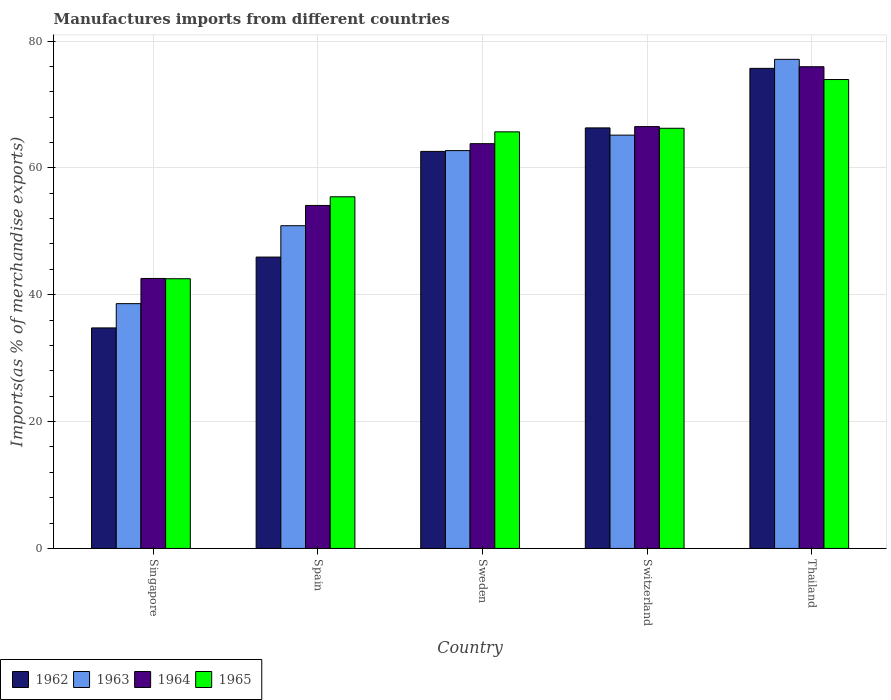How many bars are there on the 5th tick from the left?
Give a very brief answer. 4. How many bars are there on the 1st tick from the right?
Make the answer very short. 4. What is the label of the 5th group of bars from the left?
Your answer should be compact. Thailand. In how many cases, is the number of bars for a given country not equal to the number of legend labels?
Provide a short and direct response. 0. What is the percentage of imports to different countries in 1962 in Singapore?
Offer a terse response. 34.77. Across all countries, what is the maximum percentage of imports to different countries in 1964?
Provide a succinct answer. 75.95. Across all countries, what is the minimum percentage of imports to different countries in 1963?
Ensure brevity in your answer.  38.6. In which country was the percentage of imports to different countries in 1965 maximum?
Give a very brief answer. Thailand. In which country was the percentage of imports to different countries in 1964 minimum?
Give a very brief answer. Singapore. What is the total percentage of imports to different countries in 1964 in the graph?
Your answer should be very brief. 302.92. What is the difference between the percentage of imports to different countries in 1962 in Singapore and that in Thailand?
Offer a terse response. -40.92. What is the difference between the percentage of imports to different countries in 1962 in Sweden and the percentage of imports to different countries in 1963 in Spain?
Make the answer very short. 11.72. What is the average percentage of imports to different countries in 1965 per country?
Provide a short and direct response. 60.76. What is the difference between the percentage of imports to different countries of/in 1962 and percentage of imports to different countries of/in 1963 in Spain?
Your answer should be very brief. -4.94. What is the ratio of the percentage of imports to different countries in 1965 in Spain to that in Switzerland?
Ensure brevity in your answer.  0.84. What is the difference between the highest and the second highest percentage of imports to different countries in 1963?
Provide a short and direct response. -11.95. What is the difference between the highest and the lowest percentage of imports to different countries in 1962?
Offer a very short reply. 40.92. In how many countries, is the percentage of imports to different countries in 1962 greater than the average percentage of imports to different countries in 1962 taken over all countries?
Ensure brevity in your answer.  3. Is the sum of the percentage of imports to different countries in 1962 in Singapore and Sweden greater than the maximum percentage of imports to different countries in 1963 across all countries?
Offer a terse response. Yes. What does the 3rd bar from the left in Singapore represents?
Provide a short and direct response. 1964. Is it the case that in every country, the sum of the percentage of imports to different countries in 1965 and percentage of imports to different countries in 1962 is greater than the percentage of imports to different countries in 1964?
Provide a short and direct response. Yes. What is the difference between two consecutive major ticks on the Y-axis?
Make the answer very short. 20. Does the graph contain grids?
Offer a terse response. Yes. How many legend labels are there?
Make the answer very short. 4. What is the title of the graph?
Offer a very short reply. Manufactures imports from different countries. Does "1975" appear as one of the legend labels in the graph?
Your answer should be compact. No. What is the label or title of the X-axis?
Your response must be concise. Country. What is the label or title of the Y-axis?
Provide a succinct answer. Imports(as % of merchandise exports). What is the Imports(as % of merchandise exports) in 1962 in Singapore?
Offer a terse response. 34.77. What is the Imports(as % of merchandise exports) of 1963 in Singapore?
Offer a terse response. 38.6. What is the Imports(as % of merchandise exports) in 1964 in Singapore?
Your answer should be compact. 42.56. What is the Imports(as % of merchandise exports) in 1965 in Singapore?
Your answer should be very brief. 42.52. What is the Imports(as % of merchandise exports) of 1962 in Spain?
Give a very brief answer. 45.94. What is the Imports(as % of merchandise exports) in 1963 in Spain?
Offer a very short reply. 50.88. What is the Imports(as % of merchandise exports) in 1964 in Spain?
Provide a short and direct response. 54.08. What is the Imports(as % of merchandise exports) in 1965 in Spain?
Ensure brevity in your answer.  55.44. What is the Imports(as % of merchandise exports) in 1962 in Sweden?
Make the answer very short. 62.6. What is the Imports(as % of merchandise exports) in 1963 in Sweden?
Your response must be concise. 62.72. What is the Imports(as % of merchandise exports) of 1964 in Sweden?
Your answer should be compact. 63.82. What is the Imports(as % of merchandise exports) in 1965 in Sweden?
Your answer should be compact. 65.68. What is the Imports(as % of merchandise exports) of 1962 in Switzerland?
Provide a succinct answer. 66.31. What is the Imports(as % of merchandise exports) of 1963 in Switzerland?
Your answer should be very brief. 65.16. What is the Imports(as % of merchandise exports) of 1964 in Switzerland?
Provide a short and direct response. 66.51. What is the Imports(as % of merchandise exports) of 1965 in Switzerland?
Ensure brevity in your answer.  66.24. What is the Imports(as % of merchandise exports) of 1962 in Thailand?
Offer a terse response. 75.69. What is the Imports(as % of merchandise exports) in 1963 in Thailand?
Provide a succinct answer. 77.12. What is the Imports(as % of merchandise exports) in 1964 in Thailand?
Your answer should be compact. 75.95. What is the Imports(as % of merchandise exports) of 1965 in Thailand?
Offer a terse response. 73.93. Across all countries, what is the maximum Imports(as % of merchandise exports) of 1962?
Offer a very short reply. 75.69. Across all countries, what is the maximum Imports(as % of merchandise exports) in 1963?
Offer a terse response. 77.12. Across all countries, what is the maximum Imports(as % of merchandise exports) of 1964?
Make the answer very short. 75.95. Across all countries, what is the maximum Imports(as % of merchandise exports) in 1965?
Give a very brief answer. 73.93. Across all countries, what is the minimum Imports(as % of merchandise exports) in 1962?
Your answer should be compact. 34.77. Across all countries, what is the minimum Imports(as % of merchandise exports) of 1963?
Make the answer very short. 38.6. Across all countries, what is the minimum Imports(as % of merchandise exports) in 1964?
Provide a succinct answer. 42.56. Across all countries, what is the minimum Imports(as % of merchandise exports) in 1965?
Ensure brevity in your answer.  42.52. What is the total Imports(as % of merchandise exports) in 1962 in the graph?
Keep it short and to the point. 285.31. What is the total Imports(as % of merchandise exports) in 1963 in the graph?
Offer a terse response. 294.48. What is the total Imports(as % of merchandise exports) in 1964 in the graph?
Offer a very short reply. 302.92. What is the total Imports(as % of merchandise exports) of 1965 in the graph?
Keep it short and to the point. 303.82. What is the difference between the Imports(as % of merchandise exports) of 1962 in Singapore and that in Spain?
Your response must be concise. -11.17. What is the difference between the Imports(as % of merchandise exports) in 1963 in Singapore and that in Spain?
Your answer should be very brief. -12.29. What is the difference between the Imports(as % of merchandise exports) of 1964 in Singapore and that in Spain?
Make the answer very short. -11.51. What is the difference between the Imports(as % of merchandise exports) of 1965 in Singapore and that in Spain?
Your answer should be very brief. -12.92. What is the difference between the Imports(as % of merchandise exports) in 1962 in Singapore and that in Sweden?
Your response must be concise. -27.83. What is the difference between the Imports(as % of merchandise exports) of 1963 in Singapore and that in Sweden?
Ensure brevity in your answer.  -24.13. What is the difference between the Imports(as % of merchandise exports) in 1964 in Singapore and that in Sweden?
Make the answer very short. -21.25. What is the difference between the Imports(as % of merchandise exports) of 1965 in Singapore and that in Sweden?
Your answer should be very brief. -23.16. What is the difference between the Imports(as % of merchandise exports) of 1962 in Singapore and that in Switzerland?
Offer a very short reply. -31.54. What is the difference between the Imports(as % of merchandise exports) of 1963 in Singapore and that in Switzerland?
Ensure brevity in your answer.  -26.57. What is the difference between the Imports(as % of merchandise exports) in 1964 in Singapore and that in Switzerland?
Keep it short and to the point. -23.94. What is the difference between the Imports(as % of merchandise exports) of 1965 in Singapore and that in Switzerland?
Provide a succinct answer. -23.72. What is the difference between the Imports(as % of merchandise exports) of 1962 in Singapore and that in Thailand?
Offer a terse response. -40.92. What is the difference between the Imports(as % of merchandise exports) of 1963 in Singapore and that in Thailand?
Provide a succinct answer. -38.52. What is the difference between the Imports(as % of merchandise exports) in 1964 in Singapore and that in Thailand?
Your answer should be very brief. -33.38. What is the difference between the Imports(as % of merchandise exports) of 1965 in Singapore and that in Thailand?
Your response must be concise. -31.41. What is the difference between the Imports(as % of merchandise exports) in 1962 in Spain and that in Sweden?
Give a very brief answer. -16.66. What is the difference between the Imports(as % of merchandise exports) of 1963 in Spain and that in Sweden?
Your answer should be very brief. -11.84. What is the difference between the Imports(as % of merchandise exports) in 1964 in Spain and that in Sweden?
Your response must be concise. -9.74. What is the difference between the Imports(as % of merchandise exports) in 1965 in Spain and that in Sweden?
Offer a very short reply. -10.24. What is the difference between the Imports(as % of merchandise exports) in 1962 in Spain and that in Switzerland?
Your answer should be compact. -20.37. What is the difference between the Imports(as % of merchandise exports) of 1963 in Spain and that in Switzerland?
Your answer should be very brief. -14.28. What is the difference between the Imports(as % of merchandise exports) of 1964 in Spain and that in Switzerland?
Ensure brevity in your answer.  -12.43. What is the difference between the Imports(as % of merchandise exports) in 1965 in Spain and that in Switzerland?
Provide a succinct answer. -10.8. What is the difference between the Imports(as % of merchandise exports) of 1962 in Spain and that in Thailand?
Your answer should be very brief. -29.75. What is the difference between the Imports(as % of merchandise exports) in 1963 in Spain and that in Thailand?
Give a very brief answer. -26.23. What is the difference between the Imports(as % of merchandise exports) of 1964 in Spain and that in Thailand?
Offer a terse response. -21.87. What is the difference between the Imports(as % of merchandise exports) in 1965 in Spain and that in Thailand?
Offer a terse response. -18.49. What is the difference between the Imports(as % of merchandise exports) of 1962 in Sweden and that in Switzerland?
Your answer should be very brief. -3.71. What is the difference between the Imports(as % of merchandise exports) in 1963 in Sweden and that in Switzerland?
Provide a succinct answer. -2.44. What is the difference between the Imports(as % of merchandise exports) in 1964 in Sweden and that in Switzerland?
Your response must be concise. -2.69. What is the difference between the Imports(as % of merchandise exports) in 1965 in Sweden and that in Switzerland?
Provide a succinct answer. -0.56. What is the difference between the Imports(as % of merchandise exports) in 1962 in Sweden and that in Thailand?
Offer a terse response. -13.09. What is the difference between the Imports(as % of merchandise exports) of 1963 in Sweden and that in Thailand?
Give a very brief answer. -14.39. What is the difference between the Imports(as % of merchandise exports) in 1964 in Sweden and that in Thailand?
Your response must be concise. -12.13. What is the difference between the Imports(as % of merchandise exports) of 1965 in Sweden and that in Thailand?
Ensure brevity in your answer.  -8.25. What is the difference between the Imports(as % of merchandise exports) of 1962 in Switzerland and that in Thailand?
Give a very brief answer. -9.39. What is the difference between the Imports(as % of merchandise exports) in 1963 in Switzerland and that in Thailand?
Ensure brevity in your answer.  -11.95. What is the difference between the Imports(as % of merchandise exports) of 1964 in Switzerland and that in Thailand?
Your response must be concise. -9.44. What is the difference between the Imports(as % of merchandise exports) in 1965 in Switzerland and that in Thailand?
Offer a very short reply. -7.69. What is the difference between the Imports(as % of merchandise exports) in 1962 in Singapore and the Imports(as % of merchandise exports) in 1963 in Spain?
Offer a terse response. -16.11. What is the difference between the Imports(as % of merchandise exports) in 1962 in Singapore and the Imports(as % of merchandise exports) in 1964 in Spain?
Provide a succinct answer. -19.31. What is the difference between the Imports(as % of merchandise exports) of 1962 in Singapore and the Imports(as % of merchandise exports) of 1965 in Spain?
Give a very brief answer. -20.68. What is the difference between the Imports(as % of merchandise exports) of 1963 in Singapore and the Imports(as % of merchandise exports) of 1964 in Spain?
Offer a very short reply. -15.48. What is the difference between the Imports(as % of merchandise exports) of 1963 in Singapore and the Imports(as % of merchandise exports) of 1965 in Spain?
Make the answer very short. -16.85. What is the difference between the Imports(as % of merchandise exports) of 1964 in Singapore and the Imports(as % of merchandise exports) of 1965 in Spain?
Offer a very short reply. -12.88. What is the difference between the Imports(as % of merchandise exports) in 1962 in Singapore and the Imports(as % of merchandise exports) in 1963 in Sweden?
Give a very brief answer. -27.95. What is the difference between the Imports(as % of merchandise exports) of 1962 in Singapore and the Imports(as % of merchandise exports) of 1964 in Sweden?
Give a very brief answer. -29.05. What is the difference between the Imports(as % of merchandise exports) in 1962 in Singapore and the Imports(as % of merchandise exports) in 1965 in Sweden?
Give a very brief answer. -30.91. What is the difference between the Imports(as % of merchandise exports) of 1963 in Singapore and the Imports(as % of merchandise exports) of 1964 in Sweden?
Make the answer very short. -25.22. What is the difference between the Imports(as % of merchandise exports) in 1963 in Singapore and the Imports(as % of merchandise exports) in 1965 in Sweden?
Provide a short and direct response. -27.09. What is the difference between the Imports(as % of merchandise exports) in 1964 in Singapore and the Imports(as % of merchandise exports) in 1965 in Sweden?
Ensure brevity in your answer.  -23.12. What is the difference between the Imports(as % of merchandise exports) in 1962 in Singapore and the Imports(as % of merchandise exports) in 1963 in Switzerland?
Give a very brief answer. -30.4. What is the difference between the Imports(as % of merchandise exports) in 1962 in Singapore and the Imports(as % of merchandise exports) in 1964 in Switzerland?
Offer a very short reply. -31.74. What is the difference between the Imports(as % of merchandise exports) of 1962 in Singapore and the Imports(as % of merchandise exports) of 1965 in Switzerland?
Ensure brevity in your answer.  -31.48. What is the difference between the Imports(as % of merchandise exports) in 1963 in Singapore and the Imports(as % of merchandise exports) in 1964 in Switzerland?
Give a very brief answer. -27.91. What is the difference between the Imports(as % of merchandise exports) in 1963 in Singapore and the Imports(as % of merchandise exports) in 1965 in Switzerland?
Ensure brevity in your answer.  -27.65. What is the difference between the Imports(as % of merchandise exports) of 1964 in Singapore and the Imports(as % of merchandise exports) of 1965 in Switzerland?
Your response must be concise. -23.68. What is the difference between the Imports(as % of merchandise exports) of 1962 in Singapore and the Imports(as % of merchandise exports) of 1963 in Thailand?
Ensure brevity in your answer.  -42.35. What is the difference between the Imports(as % of merchandise exports) of 1962 in Singapore and the Imports(as % of merchandise exports) of 1964 in Thailand?
Keep it short and to the point. -41.18. What is the difference between the Imports(as % of merchandise exports) in 1962 in Singapore and the Imports(as % of merchandise exports) in 1965 in Thailand?
Give a very brief answer. -39.16. What is the difference between the Imports(as % of merchandise exports) in 1963 in Singapore and the Imports(as % of merchandise exports) in 1964 in Thailand?
Provide a short and direct response. -37.35. What is the difference between the Imports(as % of merchandise exports) in 1963 in Singapore and the Imports(as % of merchandise exports) in 1965 in Thailand?
Your response must be concise. -35.34. What is the difference between the Imports(as % of merchandise exports) of 1964 in Singapore and the Imports(as % of merchandise exports) of 1965 in Thailand?
Offer a very short reply. -31.37. What is the difference between the Imports(as % of merchandise exports) of 1962 in Spain and the Imports(as % of merchandise exports) of 1963 in Sweden?
Provide a short and direct response. -16.78. What is the difference between the Imports(as % of merchandise exports) in 1962 in Spain and the Imports(as % of merchandise exports) in 1964 in Sweden?
Make the answer very short. -17.88. What is the difference between the Imports(as % of merchandise exports) of 1962 in Spain and the Imports(as % of merchandise exports) of 1965 in Sweden?
Your answer should be very brief. -19.74. What is the difference between the Imports(as % of merchandise exports) of 1963 in Spain and the Imports(as % of merchandise exports) of 1964 in Sweden?
Keep it short and to the point. -12.94. What is the difference between the Imports(as % of merchandise exports) in 1963 in Spain and the Imports(as % of merchandise exports) in 1965 in Sweden?
Give a very brief answer. -14.8. What is the difference between the Imports(as % of merchandise exports) of 1964 in Spain and the Imports(as % of merchandise exports) of 1965 in Sweden?
Give a very brief answer. -11.6. What is the difference between the Imports(as % of merchandise exports) of 1962 in Spain and the Imports(as % of merchandise exports) of 1963 in Switzerland?
Your response must be concise. -19.23. What is the difference between the Imports(as % of merchandise exports) in 1962 in Spain and the Imports(as % of merchandise exports) in 1964 in Switzerland?
Ensure brevity in your answer.  -20.57. What is the difference between the Imports(as % of merchandise exports) of 1962 in Spain and the Imports(as % of merchandise exports) of 1965 in Switzerland?
Make the answer very short. -20.31. What is the difference between the Imports(as % of merchandise exports) in 1963 in Spain and the Imports(as % of merchandise exports) in 1964 in Switzerland?
Ensure brevity in your answer.  -15.63. What is the difference between the Imports(as % of merchandise exports) of 1963 in Spain and the Imports(as % of merchandise exports) of 1965 in Switzerland?
Your response must be concise. -15.36. What is the difference between the Imports(as % of merchandise exports) in 1964 in Spain and the Imports(as % of merchandise exports) in 1965 in Switzerland?
Offer a very short reply. -12.17. What is the difference between the Imports(as % of merchandise exports) in 1962 in Spain and the Imports(as % of merchandise exports) in 1963 in Thailand?
Offer a very short reply. -31.18. What is the difference between the Imports(as % of merchandise exports) of 1962 in Spain and the Imports(as % of merchandise exports) of 1964 in Thailand?
Offer a very short reply. -30.01. What is the difference between the Imports(as % of merchandise exports) of 1962 in Spain and the Imports(as % of merchandise exports) of 1965 in Thailand?
Your answer should be very brief. -27.99. What is the difference between the Imports(as % of merchandise exports) in 1963 in Spain and the Imports(as % of merchandise exports) in 1964 in Thailand?
Provide a short and direct response. -25.07. What is the difference between the Imports(as % of merchandise exports) of 1963 in Spain and the Imports(as % of merchandise exports) of 1965 in Thailand?
Make the answer very short. -23.05. What is the difference between the Imports(as % of merchandise exports) of 1964 in Spain and the Imports(as % of merchandise exports) of 1965 in Thailand?
Give a very brief answer. -19.85. What is the difference between the Imports(as % of merchandise exports) of 1962 in Sweden and the Imports(as % of merchandise exports) of 1963 in Switzerland?
Offer a terse response. -2.57. What is the difference between the Imports(as % of merchandise exports) in 1962 in Sweden and the Imports(as % of merchandise exports) in 1964 in Switzerland?
Provide a short and direct response. -3.91. What is the difference between the Imports(as % of merchandise exports) of 1962 in Sweden and the Imports(as % of merchandise exports) of 1965 in Switzerland?
Provide a succinct answer. -3.65. What is the difference between the Imports(as % of merchandise exports) of 1963 in Sweden and the Imports(as % of merchandise exports) of 1964 in Switzerland?
Your answer should be very brief. -3.78. What is the difference between the Imports(as % of merchandise exports) of 1963 in Sweden and the Imports(as % of merchandise exports) of 1965 in Switzerland?
Ensure brevity in your answer.  -3.52. What is the difference between the Imports(as % of merchandise exports) of 1964 in Sweden and the Imports(as % of merchandise exports) of 1965 in Switzerland?
Offer a very short reply. -2.43. What is the difference between the Imports(as % of merchandise exports) in 1962 in Sweden and the Imports(as % of merchandise exports) in 1963 in Thailand?
Offer a terse response. -14.52. What is the difference between the Imports(as % of merchandise exports) of 1962 in Sweden and the Imports(as % of merchandise exports) of 1964 in Thailand?
Provide a short and direct response. -13.35. What is the difference between the Imports(as % of merchandise exports) in 1962 in Sweden and the Imports(as % of merchandise exports) in 1965 in Thailand?
Make the answer very short. -11.33. What is the difference between the Imports(as % of merchandise exports) in 1963 in Sweden and the Imports(as % of merchandise exports) in 1964 in Thailand?
Provide a short and direct response. -13.23. What is the difference between the Imports(as % of merchandise exports) in 1963 in Sweden and the Imports(as % of merchandise exports) in 1965 in Thailand?
Your answer should be compact. -11.21. What is the difference between the Imports(as % of merchandise exports) in 1964 in Sweden and the Imports(as % of merchandise exports) in 1965 in Thailand?
Give a very brief answer. -10.11. What is the difference between the Imports(as % of merchandise exports) in 1962 in Switzerland and the Imports(as % of merchandise exports) in 1963 in Thailand?
Ensure brevity in your answer.  -10.81. What is the difference between the Imports(as % of merchandise exports) in 1962 in Switzerland and the Imports(as % of merchandise exports) in 1964 in Thailand?
Provide a short and direct response. -9.64. What is the difference between the Imports(as % of merchandise exports) in 1962 in Switzerland and the Imports(as % of merchandise exports) in 1965 in Thailand?
Your answer should be very brief. -7.63. What is the difference between the Imports(as % of merchandise exports) of 1963 in Switzerland and the Imports(as % of merchandise exports) of 1964 in Thailand?
Provide a succinct answer. -10.78. What is the difference between the Imports(as % of merchandise exports) in 1963 in Switzerland and the Imports(as % of merchandise exports) in 1965 in Thailand?
Your answer should be compact. -8.77. What is the difference between the Imports(as % of merchandise exports) in 1964 in Switzerland and the Imports(as % of merchandise exports) in 1965 in Thailand?
Keep it short and to the point. -7.42. What is the average Imports(as % of merchandise exports) of 1962 per country?
Offer a terse response. 57.06. What is the average Imports(as % of merchandise exports) in 1963 per country?
Your answer should be compact. 58.9. What is the average Imports(as % of merchandise exports) in 1964 per country?
Your response must be concise. 60.58. What is the average Imports(as % of merchandise exports) of 1965 per country?
Give a very brief answer. 60.76. What is the difference between the Imports(as % of merchandise exports) of 1962 and Imports(as % of merchandise exports) of 1963 in Singapore?
Provide a short and direct response. -3.83. What is the difference between the Imports(as % of merchandise exports) of 1962 and Imports(as % of merchandise exports) of 1964 in Singapore?
Your answer should be very brief. -7.8. What is the difference between the Imports(as % of merchandise exports) of 1962 and Imports(as % of merchandise exports) of 1965 in Singapore?
Give a very brief answer. -7.75. What is the difference between the Imports(as % of merchandise exports) of 1963 and Imports(as % of merchandise exports) of 1964 in Singapore?
Provide a short and direct response. -3.97. What is the difference between the Imports(as % of merchandise exports) of 1963 and Imports(as % of merchandise exports) of 1965 in Singapore?
Keep it short and to the point. -3.93. What is the difference between the Imports(as % of merchandise exports) of 1964 and Imports(as % of merchandise exports) of 1965 in Singapore?
Give a very brief answer. 0.04. What is the difference between the Imports(as % of merchandise exports) in 1962 and Imports(as % of merchandise exports) in 1963 in Spain?
Offer a very short reply. -4.94. What is the difference between the Imports(as % of merchandise exports) of 1962 and Imports(as % of merchandise exports) of 1964 in Spain?
Keep it short and to the point. -8.14. What is the difference between the Imports(as % of merchandise exports) of 1962 and Imports(as % of merchandise exports) of 1965 in Spain?
Make the answer very short. -9.51. What is the difference between the Imports(as % of merchandise exports) in 1963 and Imports(as % of merchandise exports) in 1964 in Spain?
Offer a very short reply. -3.2. What is the difference between the Imports(as % of merchandise exports) in 1963 and Imports(as % of merchandise exports) in 1965 in Spain?
Ensure brevity in your answer.  -4.56. What is the difference between the Imports(as % of merchandise exports) in 1964 and Imports(as % of merchandise exports) in 1965 in Spain?
Keep it short and to the point. -1.37. What is the difference between the Imports(as % of merchandise exports) in 1962 and Imports(as % of merchandise exports) in 1963 in Sweden?
Your response must be concise. -0.12. What is the difference between the Imports(as % of merchandise exports) in 1962 and Imports(as % of merchandise exports) in 1964 in Sweden?
Keep it short and to the point. -1.22. What is the difference between the Imports(as % of merchandise exports) in 1962 and Imports(as % of merchandise exports) in 1965 in Sweden?
Provide a short and direct response. -3.08. What is the difference between the Imports(as % of merchandise exports) in 1963 and Imports(as % of merchandise exports) in 1964 in Sweden?
Your answer should be very brief. -1.09. What is the difference between the Imports(as % of merchandise exports) in 1963 and Imports(as % of merchandise exports) in 1965 in Sweden?
Keep it short and to the point. -2.96. What is the difference between the Imports(as % of merchandise exports) of 1964 and Imports(as % of merchandise exports) of 1965 in Sweden?
Give a very brief answer. -1.87. What is the difference between the Imports(as % of merchandise exports) in 1962 and Imports(as % of merchandise exports) in 1963 in Switzerland?
Your response must be concise. 1.14. What is the difference between the Imports(as % of merchandise exports) in 1962 and Imports(as % of merchandise exports) in 1964 in Switzerland?
Provide a short and direct response. -0.2. What is the difference between the Imports(as % of merchandise exports) in 1962 and Imports(as % of merchandise exports) in 1965 in Switzerland?
Offer a terse response. 0.06. What is the difference between the Imports(as % of merchandise exports) in 1963 and Imports(as % of merchandise exports) in 1964 in Switzerland?
Offer a terse response. -1.34. What is the difference between the Imports(as % of merchandise exports) in 1963 and Imports(as % of merchandise exports) in 1965 in Switzerland?
Offer a very short reply. -1.08. What is the difference between the Imports(as % of merchandise exports) of 1964 and Imports(as % of merchandise exports) of 1965 in Switzerland?
Give a very brief answer. 0.26. What is the difference between the Imports(as % of merchandise exports) of 1962 and Imports(as % of merchandise exports) of 1963 in Thailand?
Your response must be concise. -1.42. What is the difference between the Imports(as % of merchandise exports) in 1962 and Imports(as % of merchandise exports) in 1964 in Thailand?
Keep it short and to the point. -0.26. What is the difference between the Imports(as % of merchandise exports) of 1962 and Imports(as % of merchandise exports) of 1965 in Thailand?
Keep it short and to the point. 1.76. What is the difference between the Imports(as % of merchandise exports) in 1963 and Imports(as % of merchandise exports) in 1964 in Thailand?
Your answer should be compact. 1.17. What is the difference between the Imports(as % of merchandise exports) in 1963 and Imports(as % of merchandise exports) in 1965 in Thailand?
Your answer should be compact. 3.18. What is the difference between the Imports(as % of merchandise exports) in 1964 and Imports(as % of merchandise exports) in 1965 in Thailand?
Offer a terse response. 2.02. What is the ratio of the Imports(as % of merchandise exports) in 1962 in Singapore to that in Spain?
Your response must be concise. 0.76. What is the ratio of the Imports(as % of merchandise exports) in 1963 in Singapore to that in Spain?
Your answer should be compact. 0.76. What is the ratio of the Imports(as % of merchandise exports) in 1964 in Singapore to that in Spain?
Your answer should be very brief. 0.79. What is the ratio of the Imports(as % of merchandise exports) in 1965 in Singapore to that in Spain?
Provide a succinct answer. 0.77. What is the ratio of the Imports(as % of merchandise exports) of 1962 in Singapore to that in Sweden?
Offer a terse response. 0.56. What is the ratio of the Imports(as % of merchandise exports) in 1963 in Singapore to that in Sweden?
Your answer should be very brief. 0.62. What is the ratio of the Imports(as % of merchandise exports) of 1964 in Singapore to that in Sweden?
Your answer should be compact. 0.67. What is the ratio of the Imports(as % of merchandise exports) of 1965 in Singapore to that in Sweden?
Keep it short and to the point. 0.65. What is the ratio of the Imports(as % of merchandise exports) of 1962 in Singapore to that in Switzerland?
Offer a terse response. 0.52. What is the ratio of the Imports(as % of merchandise exports) in 1963 in Singapore to that in Switzerland?
Provide a succinct answer. 0.59. What is the ratio of the Imports(as % of merchandise exports) in 1964 in Singapore to that in Switzerland?
Your answer should be compact. 0.64. What is the ratio of the Imports(as % of merchandise exports) of 1965 in Singapore to that in Switzerland?
Your response must be concise. 0.64. What is the ratio of the Imports(as % of merchandise exports) of 1962 in Singapore to that in Thailand?
Offer a very short reply. 0.46. What is the ratio of the Imports(as % of merchandise exports) of 1963 in Singapore to that in Thailand?
Keep it short and to the point. 0.5. What is the ratio of the Imports(as % of merchandise exports) of 1964 in Singapore to that in Thailand?
Give a very brief answer. 0.56. What is the ratio of the Imports(as % of merchandise exports) of 1965 in Singapore to that in Thailand?
Give a very brief answer. 0.58. What is the ratio of the Imports(as % of merchandise exports) in 1962 in Spain to that in Sweden?
Offer a terse response. 0.73. What is the ratio of the Imports(as % of merchandise exports) of 1963 in Spain to that in Sweden?
Provide a short and direct response. 0.81. What is the ratio of the Imports(as % of merchandise exports) in 1964 in Spain to that in Sweden?
Ensure brevity in your answer.  0.85. What is the ratio of the Imports(as % of merchandise exports) in 1965 in Spain to that in Sweden?
Your answer should be very brief. 0.84. What is the ratio of the Imports(as % of merchandise exports) in 1962 in Spain to that in Switzerland?
Your response must be concise. 0.69. What is the ratio of the Imports(as % of merchandise exports) of 1963 in Spain to that in Switzerland?
Provide a succinct answer. 0.78. What is the ratio of the Imports(as % of merchandise exports) in 1964 in Spain to that in Switzerland?
Your answer should be very brief. 0.81. What is the ratio of the Imports(as % of merchandise exports) in 1965 in Spain to that in Switzerland?
Your answer should be compact. 0.84. What is the ratio of the Imports(as % of merchandise exports) of 1962 in Spain to that in Thailand?
Provide a short and direct response. 0.61. What is the ratio of the Imports(as % of merchandise exports) of 1963 in Spain to that in Thailand?
Offer a terse response. 0.66. What is the ratio of the Imports(as % of merchandise exports) of 1964 in Spain to that in Thailand?
Your answer should be compact. 0.71. What is the ratio of the Imports(as % of merchandise exports) in 1965 in Spain to that in Thailand?
Your answer should be compact. 0.75. What is the ratio of the Imports(as % of merchandise exports) in 1962 in Sweden to that in Switzerland?
Your response must be concise. 0.94. What is the ratio of the Imports(as % of merchandise exports) of 1963 in Sweden to that in Switzerland?
Ensure brevity in your answer.  0.96. What is the ratio of the Imports(as % of merchandise exports) in 1964 in Sweden to that in Switzerland?
Keep it short and to the point. 0.96. What is the ratio of the Imports(as % of merchandise exports) of 1965 in Sweden to that in Switzerland?
Your response must be concise. 0.99. What is the ratio of the Imports(as % of merchandise exports) in 1962 in Sweden to that in Thailand?
Your answer should be compact. 0.83. What is the ratio of the Imports(as % of merchandise exports) in 1963 in Sweden to that in Thailand?
Your answer should be very brief. 0.81. What is the ratio of the Imports(as % of merchandise exports) in 1964 in Sweden to that in Thailand?
Offer a very short reply. 0.84. What is the ratio of the Imports(as % of merchandise exports) of 1965 in Sweden to that in Thailand?
Offer a terse response. 0.89. What is the ratio of the Imports(as % of merchandise exports) of 1962 in Switzerland to that in Thailand?
Provide a succinct answer. 0.88. What is the ratio of the Imports(as % of merchandise exports) of 1963 in Switzerland to that in Thailand?
Ensure brevity in your answer.  0.84. What is the ratio of the Imports(as % of merchandise exports) of 1964 in Switzerland to that in Thailand?
Your answer should be compact. 0.88. What is the ratio of the Imports(as % of merchandise exports) in 1965 in Switzerland to that in Thailand?
Offer a terse response. 0.9. What is the difference between the highest and the second highest Imports(as % of merchandise exports) in 1962?
Make the answer very short. 9.39. What is the difference between the highest and the second highest Imports(as % of merchandise exports) of 1963?
Your answer should be compact. 11.95. What is the difference between the highest and the second highest Imports(as % of merchandise exports) in 1964?
Offer a terse response. 9.44. What is the difference between the highest and the second highest Imports(as % of merchandise exports) in 1965?
Your response must be concise. 7.69. What is the difference between the highest and the lowest Imports(as % of merchandise exports) of 1962?
Offer a terse response. 40.92. What is the difference between the highest and the lowest Imports(as % of merchandise exports) in 1963?
Offer a terse response. 38.52. What is the difference between the highest and the lowest Imports(as % of merchandise exports) of 1964?
Provide a succinct answer. 33.38. What is the difference between the highest and the lowest Imports(as % of merchandise exports) in 1965?
Ensure brevity in your answer.  31.41. 